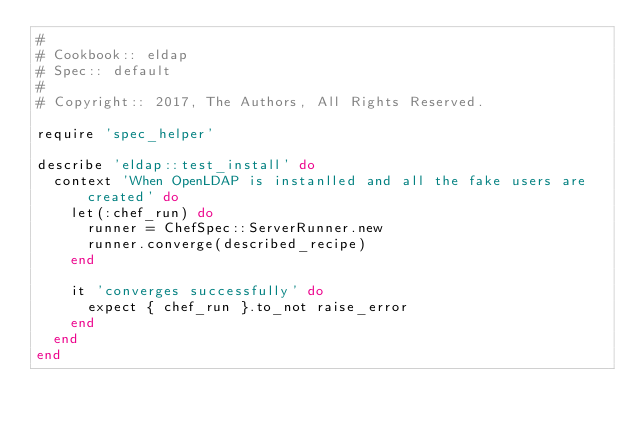Convert code to text. <code><loc_0><loc_0><loc_500><loc_500><_Ruby_>#
# Cookbook:: eldap
# Spec:: default
#
# Copyright:: 2017, The Authors, All Rights Reserved.

require 'spec_helper'

describe 'eldap::test_install' do
  context 'When OpenLDAP is instanlled and all the fake users are created' do
    let(:chef_run) do
      runner = ChefSpec::ServerRunner.new
      runner.converge(described_recipe)
    end

    it 'converges successfully' do
      expect { chef_run }.to_not raise_error
    end
  end
end
</code> 